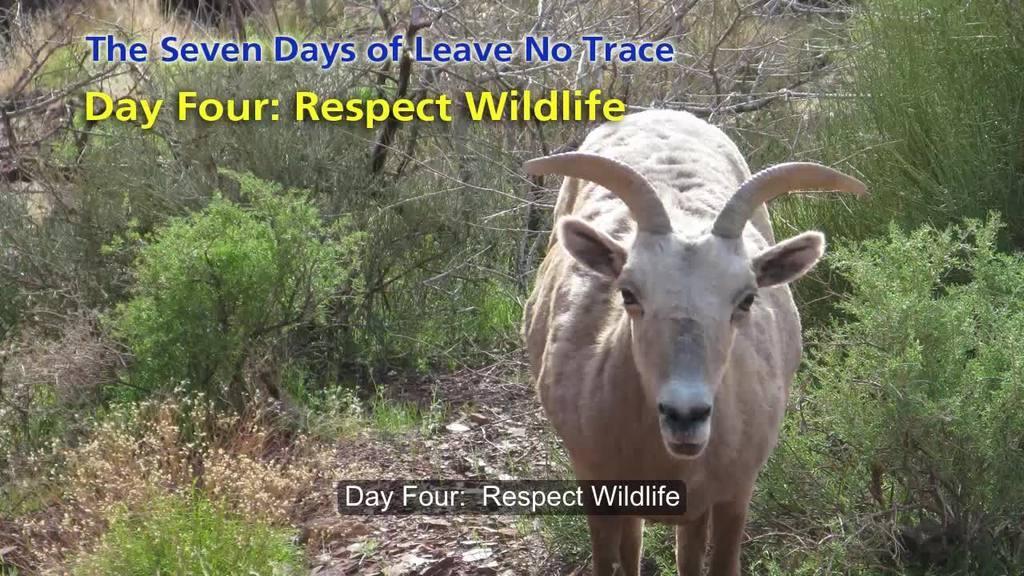Could you give a brief overview of what you see in this image? Here in this picture we can see a goat present on the ground and we can see plants and trees on the ground and we can also see some text present on the picture. 